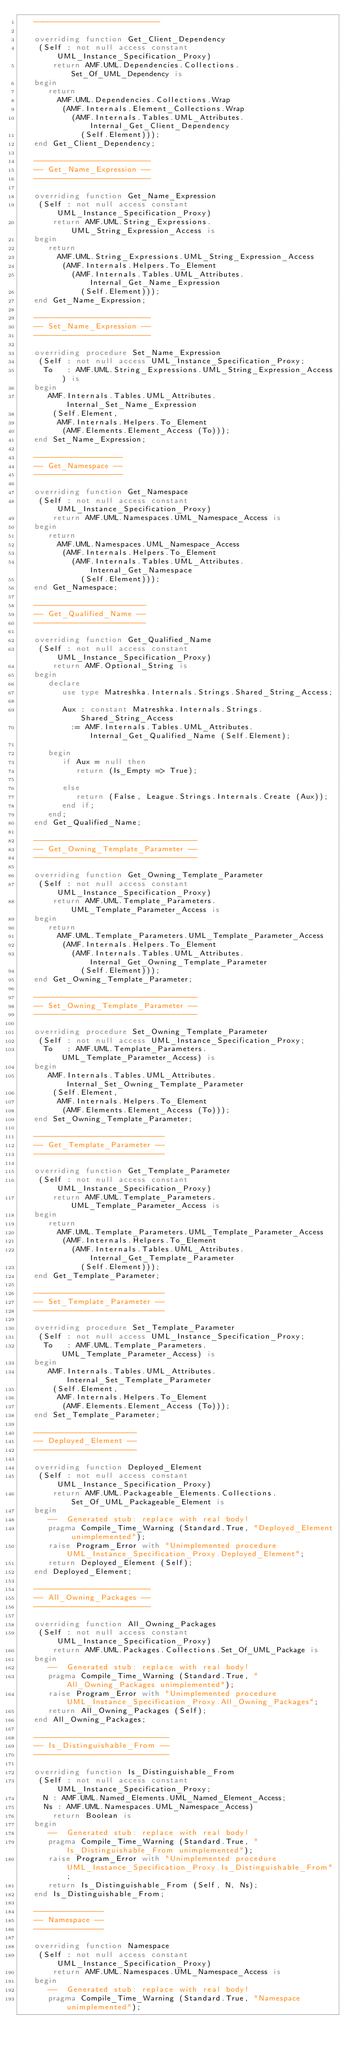Convert code to text. <code><loc_0><loc_0><loc_500><loc_500><_Ada_>   ---------------------------

   overriding function Get_Client_Dependency
    (Self : not null access constant UML_Instance_Specification_Proxy)
       return AMF.UML.Dependencies.Collections.Set_Of_UML_Dependency is
   begin
      return
        AMF.UML.Dependencies.Collections.Wrap
         (AMF.Internals.Element_Collections.Wrap
           (AMF.Internals.Tables.UML_Attributes.Internal_Get_Client_Dependency
             (Self.Element)));
   end Get_Client_Dependency;

   -------------------------
   -- Get_Name_Expression --
   -------------------------

   overriding function Get_Name_Expression
    (Self : not null access constant UML_Instance_Specification_Proxy)
       return AMF.UML.String_Expressions.UML_String_Expression_Access is
   begin
      return
        AMF.UML.String_Expressions.UML_String_Expression_Access
         (AMF.Internals.Helpers.To_Element
           (AMF.Internals.Tables.UML_Attributes.Internal_Get_Name_Expression
             (Self.Element)));
   end Get_Name_Expression;

   -------------------------
   -- Set_Name_Expression --
   -------------------------

   overriding procedure Set_Name_Expression
    (Self : not null access UML_Instance_Specification_Proxy;
     To   : AMF.UML.String_Expressions.UML_String_Expression_Access) is
   begin
      AMF.Internals.Tables.UML_Attributes.Internal_Set_Name_Expression
       (Self.Element,
        AMF.Internals.Helpers.To_Element
         (AMF.Elements.Element_Access (To)));
   end Set_Name_Expression;

   -------------------
   -- Get_Namespace --
   -------------------

   overriding function Get_Namespace
    (Self : not null access constant UML_Instance_Specification_Proxy)
       return AMF.UML.Namespaces.UML_Namespace_Access is
   begin
      return
        AMF.UML.Namespaces.UML_Namespace_Access
         (AMF.Internals.Helpers.To_Element
           (AMF.Internals.Tables.UML_Attributes.Internal_Get_Namespace
             (Self.Element)));
   end Get_Namespace;

   ------------------------
   -- Get_Qualified_Name --
   ------------------------

   overriding function Get_Qualified_Name
    (Self : not null access constant UML_Instance_Specification_Proxy)
       return AMF.Optional_String is
   begin
      declare
         use type Matreshka.Internals.Strings.Shared_String_Access;

         Aux : constant Matreshka.Internals.Strings.Shared_String_Access
           := AMF.Internals.Tables.UML_Attributes.Internal_Get_Qualified_Name (Self.Element);

      begin
         if Aux = null then
            return (Is_Empty => True);

         else
            return (False, League.Strings.Internals.Create (Aux));
         end if;
      end;
   end Get_Qualified_Name;

   -----------------------------------
   -- Get_Owning_Template_Parameter --
   -----------------------------------

   overriding function Get_Owning_Template_Parameter
    (Self : not null access constant UML_Instance_Specification_Proxy)
       return AMF.UML.Template_Parameters.UML_Template_Parameter_Access is
   begin
      return
        AMF.UML.Template_Parameters.UML_Template_Parameter_Access
         (AMF.Internals.Helpers.To_Element
           (AMF.Internals.Tables.UML_Attributes.Internal_Get_Owning_Template_Parameter
             (Self.Element)));
   end Get_Owning_Template_Parameter;

   -----------------------------------
   -- Set_Owning_Template_Parameter --
   -----------------------------------

   overriding procedure Set_Owning_Template_Parameter
    (Self : not null access UML_Instance_Specification_Proxy;
     To   : AMF.UML.Template_Parameters.UML_Template_Parameter_Access) is
   begin
      AMF.Internals.Tables.UML_Attributes.Internal_Set_Owning_Template_Parameter
       (Self.Element,
        AMF.Internals.Helpers.To_Element
         (AMF.Elements.Element_Access (To)));
   end Set_Owning_Template_Parameter;

   ----------------------------
   -- Get_Template_Parameter --
   ----------------------------

   overriding function Get_Template_Parameter
    (Self : not null access constant UML_Instance_Specification_Proxy)
       return AMF.UML.Template_Parameters.UML_Template_Parameter_Access is
   begin
      return
        AMF.UML.Template_Parameters.UML_Template_Parameter_Access
         (AMF.Internals.Helpers.To_Element
           (AMF.Internals.Tables.UML_Attributes.Internal_Get_Template_Parameter
             (Self.Element)));
   end Get_Template_Parameter;

   ----------------------------
   -- Set_Template_Parameter --
   ----------------------------

   overriding procedure Set_Template_Parameter
    (Self : not null access UML_Instance_Specification_Proxy;
     To   : AMF.UML.Template_Parameters.UML_Template_Parameter_Access) is
   begin
      AMF.Internals.Tables.UML_Attributes.Internal_Set_Template_Parameter
       (Self.Element,
        AMF.Internals.Helpers.To_Element
         (AMF.Elements.Element_Access (To)));
   end Set_Template_Parameter;

   ----------------------
   -- Deployed_Element --
   ----------------------

   overriding function Deployed_Element
    (Self : not null access constant UML_Instance_Specification_Proxy)
       return AMF.UML.Packageable_Elements.Collections.Set_Of_UML_Packageable_Element is
   begin
      --  Generated stub: replace with real body!
      pragma Compile_Time_Warning (Standard.True, "Deployed_Element unimplemented");
      raise Program_Error with "Unimplemented procedure UML_Instance_Specification_Proxy.Deployed_Element";
      return Deployed_Element (Self);
   end Deployed_Element;

   -------------------------
   -- All_Owning_Packages --
   -------------------------

   overriding function All_Owning_Packages
    (Self : not null access constant UML_Instance_Specification_Proxy)
       return AMF.UML.Packages.Collections.Set_Of_UML_Package is
   begin
      --  Generated stub: replace with real body!
      pragma Compile_Time_Warning (Standard.True, "All_Owning_Packages unimplemented");
      raise Program_Error with "Unimplemented procedure UML_Instance_Specification_Proxy.All_Owning_Packages";
      return All_Owning_Packages (Self);
   end All_Owning_Packages;

   -----------------------------
   -- Is_Distinguishable_From --
   -----------------------------

   overriding function Is_Distinguishable_From
    (Self : not null access constant UML_Instance_Specification_Proxy;
     N : AMF.UML.Named_Elements.UML_Named_Element_Access;
     Ns : AMF.UML.Namespaces.UML_Namespace_Access)
       return Boolean is
   begin
      --  Generated stub: replace with real body!
      pragma Compile_Time_Warning (Standard.True, "Is_Distinguishable_From unimplemented");
      raise Program_Error with "Unimplemented procedure UML_Instance_Specification_Proxy.Is_Distinguishable_From";
      return Is_Distinguishable_From (Self, N, Ns);
   end Is_Distinguishable_From;

   ---------------
   -- Namespace --
   ---------------

   overriding function Namespace
    (Self : not null access constant UML_Instance_Specification_Proxy)
       return AMF.UML.Namespaces.UML_Namespace_Access is
   begin
      --  Generated stub: replace with real body!
      pragma Compile_Time_Warning (Standard.True, "Namespace unimplemented");</code> 